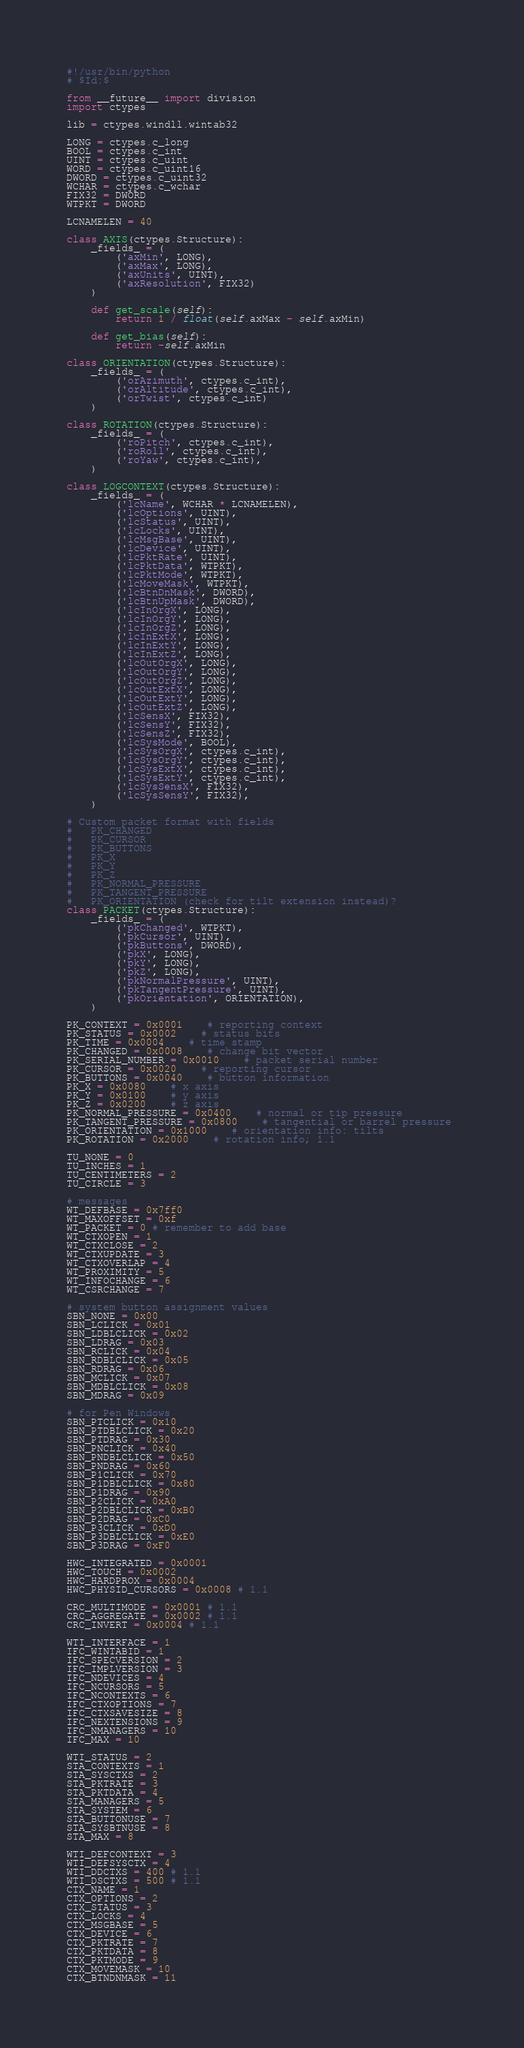Convert code to text. <code><loc_0><loc_0><loc_500><loc_500><_Python_>#!/usr/bin/python
# $Id:$

from __future__ import division
import ctypes

lib = ctypes.windll.wintab32

LONG = ctypes.c_long
BOOL = ctypes.c_int
UINT = ctypes.c_uint
WORD = ctypes.c_uint16
DWORD = ctypes.c_uint32
WCHAR = ctypes.c_wchar
FIX32 = DWORD
WTPKT = DWORD

LCNAMELEN = 40

class AXIS(ctypes.Structure):
    _fields_ = (
        ('axMin', LONG),
        ('axMax', LONG),
        ('axUnits', UINT),
        ('axResolution', FIX32)
    )

    def get_scale(self):
        return 1 / float(self.axMax - self.axMin)

    def get_bias(self):
        return -self.axMin

class ORIENTATION(ctypes.Structure):
    _fields_ = (
        ('orAzimuth', ctypes.c_int),
        ('orAltitude', ctypes.c_int),
        ('orTwist', ctypes.c_int)
    )

class ROTATION(ctypes.Structure):
    _fields_ = (
        ('roPitch', ctypes.c_int),
        ('roRoll', ctypes.c_int),
        ('roYaw', ctypes.c_int),
    )

class LOGCONTEXT(ctypes.Structure):
    _fields_ = (
        ('lcName', WCHAR * LCNAMELEN),
        ('lcOptions', UINT),
        ('lcStatus', UINT),
        ('lcLocks', UINT),
        ('lcMsgBase', UINT),
        ('lcDevice', UINT),
        ('lcPktRate', UINT),
        ('lcPktData', WTPKT),
        ('lcPktMode', WTPKT),
        ('lcMoveMask', WTPKT),
        ('lcBtnDnMask', DWORD),
        ('lcBtnUpMask', DWORD),
        ('lcInOrgX', LONG),
        ('lcInOrgY', LONG),
        ('lcInOrgZ', LONG),
        ('lcInExtX', LONG),
        ('lcInExtY', LONG),
        ('lcInExtZ', LONG),
        ('lcOutOrgX', LONG),
        ('lcOutOrgY', LONG),
        ('lcOutOrgZ', LONG),
        ('lcOutExtX', LONG),
        ('lcOutExtY', LONG),
        ('lcOutExtZ', LONG),
        ('lcSensX', FIX32),
        ('lcSensY', FIX32),
        ('lcSensZ', FIX32),
        ('lcSysMode', BOOL),
        ('lcSysOrgX', ctypes.c_int),
        ('lcSysOrgY', ctypes.c_int),
        ('lcSysExtX', ctypes.c_int),
        ('lcSysExtY', ctypes.c_int),
        ('lcSysSensX', FIX32),
        ('lcSysSensY', FIX32),
    )

# Custom packet format with fields 
#   PK_CHANGED
#   PK_CURSOR
#   PK_BUTTONS
#   PK_X
#   PK_Y
#   PK_Z
#   PK_NORMAL_PRESSURE
#   PK_TANGENT_PRESSURE
#   PK_ORIENTATION (check for tilt extension instead)?
class PACKET(ctypes.Structure):
    _fields_ = (
        ('pkChanged', WTPKT),
        ('pkCursor', UINT),
        ('pkButtons', DWORD),
        ('pkX', LONG),
        ('pkY', LONG),
        ('pkZ', LONG),
        ('pkNormalPressure', UINT),
        ('pkTangentPressure', UINT),
        ('pkOrientation', ORIENTATION),
    )

PK_CONTEXT = 0x0001	# reporting context 
PK_STATUS = 0x0002	# status bits 
PK_TIME = 0x0004	# time stamp 
PK_CHANGED = 0x0008	# change bit vector 
PK_SERIAL_NUMBER = 0x0010	# packet serial number 
PK_CURSOR = 0x0020	# reporting cursor 
PK_BUTTONS = 0x0040	# button information 
PK_X = 0x0080	# x axis 
PK_Y = 0x0100	# y axis 
PK_Z = 0x0200	# z axis 
PK_NORMAL_PRESSURE = 0x0400	# normal or tip pressure 
PK_TANGENT_PRESSURE = 0x0800	# tangential or barrel pressure 
PK_ORIENTATION = 0x1000	# orientation info: tilts 
PK_ROTATION = 0x2000	# rotation info; 1.1 

TU_NONE = 0
TU_INCHES = 1
TU_CENTIMETERS = 2
TU_CIRCLE = 3

# messages
WT_DEFBASE = 0x7ff0
WT_MAXOFFSET = 0xf
WT_PACKET = 0 # remember to add base
WT_CTXOPEN = 1
WT_CTXCLOSE = 2
WT_CTXUPDATE = 3
WT_CTXOVERLAP = 4
WT_PROXIMITY = 5
WT_INFOCHANGE = 6
WT_CSRCHANGE = 7

# system button assignment values 
SBN_NONE = 0x00
SBN_LCLICK = 0x01
SBN_LDBLCLICK = 0x02
SBN_LDRAG = 0x03
SBN_RCLICK = 0x04
SBN_RDBLCLICK = 0x05
SBN_RDRAG = 0x06
SBN_MCLICK = 0x07
SBN_MDBLCLICK = 0x08
SBN_MDRAG = 0x09

# for Pen Windows 
SBN_PTCLICK = 0x10
SBN_PTDBLCLICK = 0x20
SBN_PTDRAG = 0x30
SBN_PNCLICK = 0x40
SBN_PNDBLCLICK = 0x50
SBN_PNDRAG = 0x60
SBN_P1CLICK = 0x70
SBN_P1DBLCLICK = 0x80
SBN_P1DRAG = 0x90
SBN_P2CLICK = 0xA0
SBN_P2DBLCLICK = 0xB0
SBN_P2DRAG = 0xC0
SBN_P3CLICK = 0xD0
SBN_P3DBLCLICK = 0xE0
SBN_P3DRAG = 0xF0

HWC_INTEGRATED = 0x0001
HWC_TOUCH = 0x0002
HWC_HARDPROX = 0x0004
HWC_PHYSID_CURSORS = 0x0008 # 1.1 

CRC_MULTIMODE = 0x0001 # 1.1 
CRC_AGGREGATE = 0x0002 # 1.1 
CRC_INVERT = 0x0004 # 1.1 

WTI_INTERFACE = 1
IFC_WINTABID = 1
IFC_SPECVERSION = 2
IFC_IMPLVERSION = 3
IFC_NDEVICES = 4
IFC_NCURSORS = 5
IFC_NCONTEXTS = 6
IFC_CTXOPTIONS = 7
IFC_CTXSAVESIZE = 8
IFC_NEXTENSIONS = 9
IFC_NMANAGERS = 10
IFC_MAX = 10

WTI_STATUS = 2
STA_CONTEXTS = 1
STA_SYSCTXS = 2
STA_PKTRATE = 3
STA_PKTDATA = 4
STA_MANAGERS = 5
STA_SYSTEM = 6
STA_BUTTONUSE = 7
STA_SYSBTNUSE = 8
STA_MAX = 8

WTI_DEFCONTEXT = 3
WTI_DEFSYSCTX = 4
WTI_DDCTXS = 400 # 1.1 
WTI_DSCTXS = 500 # 1.1 
CTX_NAME = 1
CTX_OPTIONS = 2
CTX_STATUS = 3
CTX_LOCKS = 4
CTX_MSGBASE = 5
CTX_DEVICE = 6
CTX_PKTRATE = 7
CTX_PKTDATA = 8
CTX_PKTMODE = 9
CTX_MOVEMASK = 10
CTX_BTNDNMASK = 11</code> 